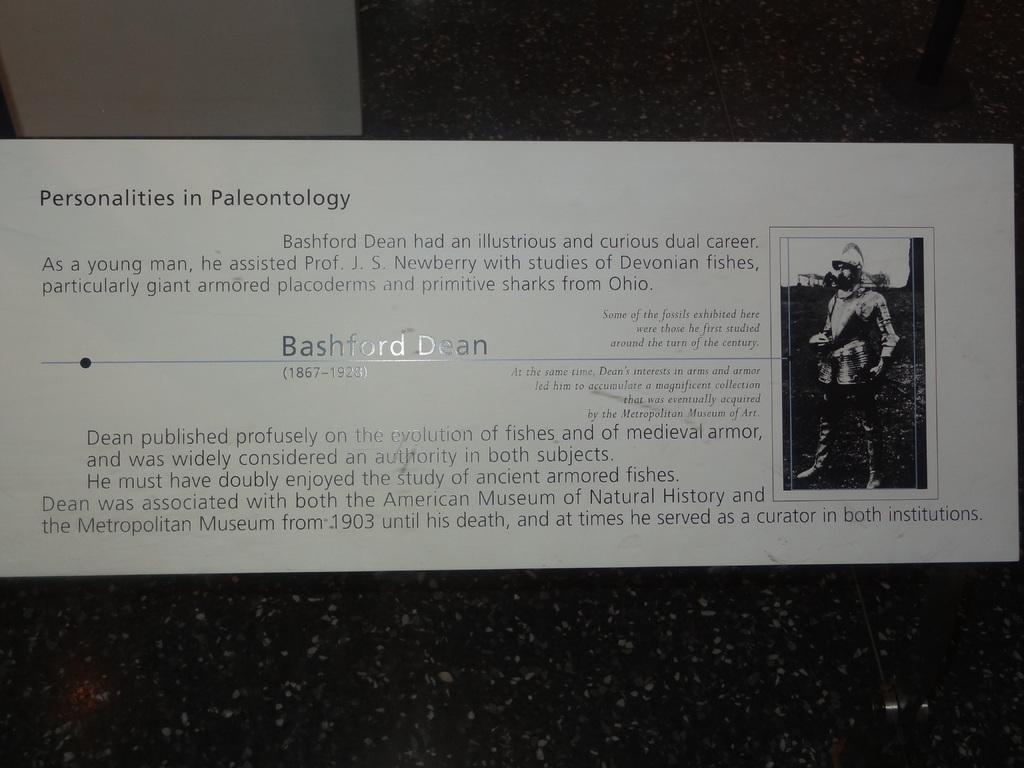What is on the wall in the image? There is a poster placed on the wall in the image. What is the man in the image doing? The man is standing in front of a mic in the image. Can you describe the location of the poster in the image? The poster is placed on a wall in the image. What type of plastic is used to make the mic in the image? There is no mention of plastic or any specific material used for the mic in the image. 